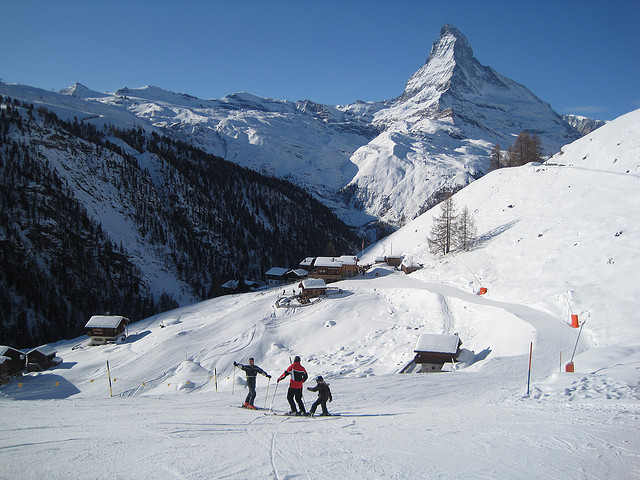Can you tell me more about the Matterhorn's significance? Certainly! The Matterhorn is not only one of the most recognizable mountains in the world due to its almost perfect pyramidal shape, but it's also steeped in mountaineering history. It was one of the last great Alpine peaks to be climbed, with the first ascent in 1865 marked by triumph and tragedy. Since then, it has become a symbol of the Alps and mountain climbing in general. What kind of wildlife might be present in this region? The region around the Matterhorn is rich with Alpine wildlife. Common species include marmots, chamois, ibex, and eagles. The diverse ecosystems in the area support a range of flora and fauna adapted to the alpine conditions. 